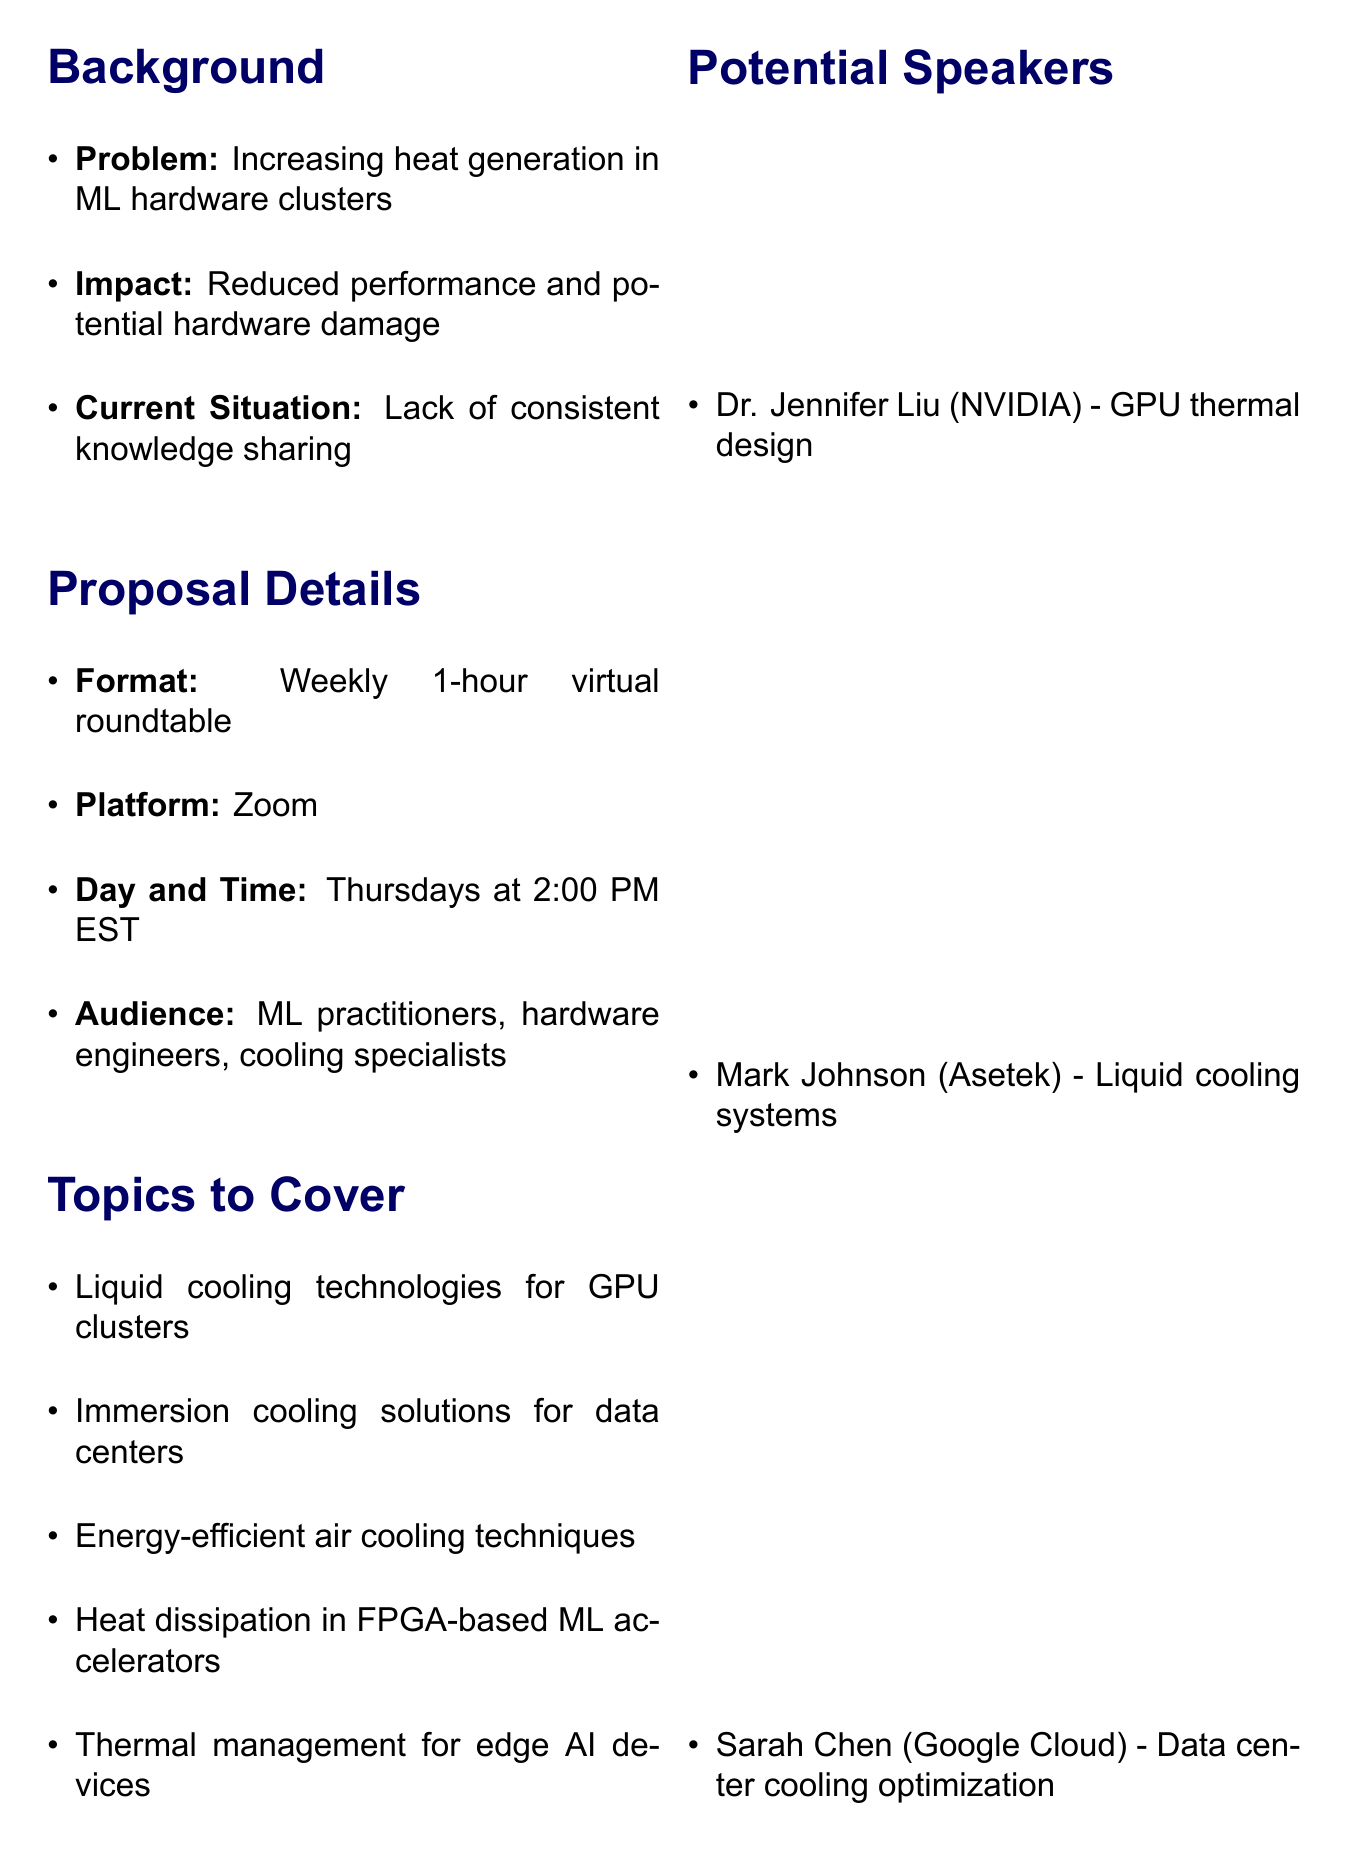what is the main problem addressed by the proposal? The main problem is the increasing heat generation in ML hardware clusters.
Answer: increasing heat generation in ML hardware clusters when will the roundtable meetings take place? The roundtable meetings are scheduled for Thursdays at 2:00 PM EST.
Answer: Thursdays at 2:00 PM EST who is the proposed moderator for the roundtable? The proposed moderator is an experienced forum moderator.
Answer: Experienced forum moderator how many topics are suggested to cover in the roundtable? The document lists five topics to cover in the roundtable.
Answer: five name one potential speaker and their expertise. One potential speaker is Dr. Jennifer Liu, who specializes in GPU thermal design.
Answer: Dr. Jennifer Liu - GPU thermal design what is one expected outcome of the roundtable meetings? One expected outcome is increased awareness of cutting-edge cooling solutions.
Answer: Increased awareness of cutting-edge cooling solutions what is a potential challenge mentioned in the proposal? A potential challenge is maintaining consistent attendance.
Answer: maintaining consistent attendance what is the target audience for the virtual roundtable? The target audience includes ML practitioners, hardware engineers, and cooling specialists.
Answer: ML practitioners, hardware engineers, and cooling specialists 